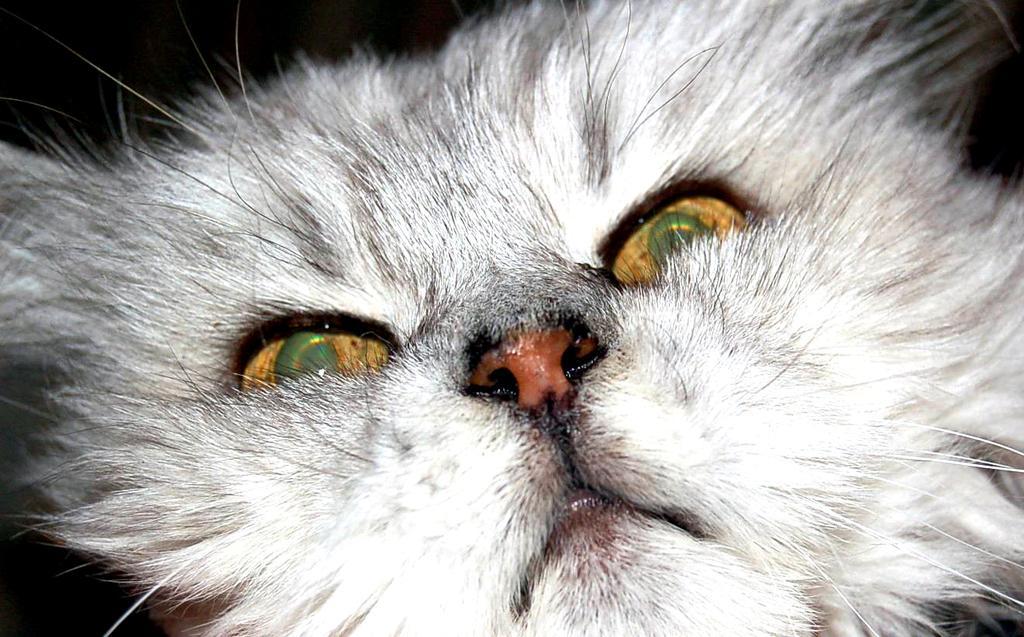Describe this image in one or two sentences. In this image we can see a white color cat and the background is dark. 